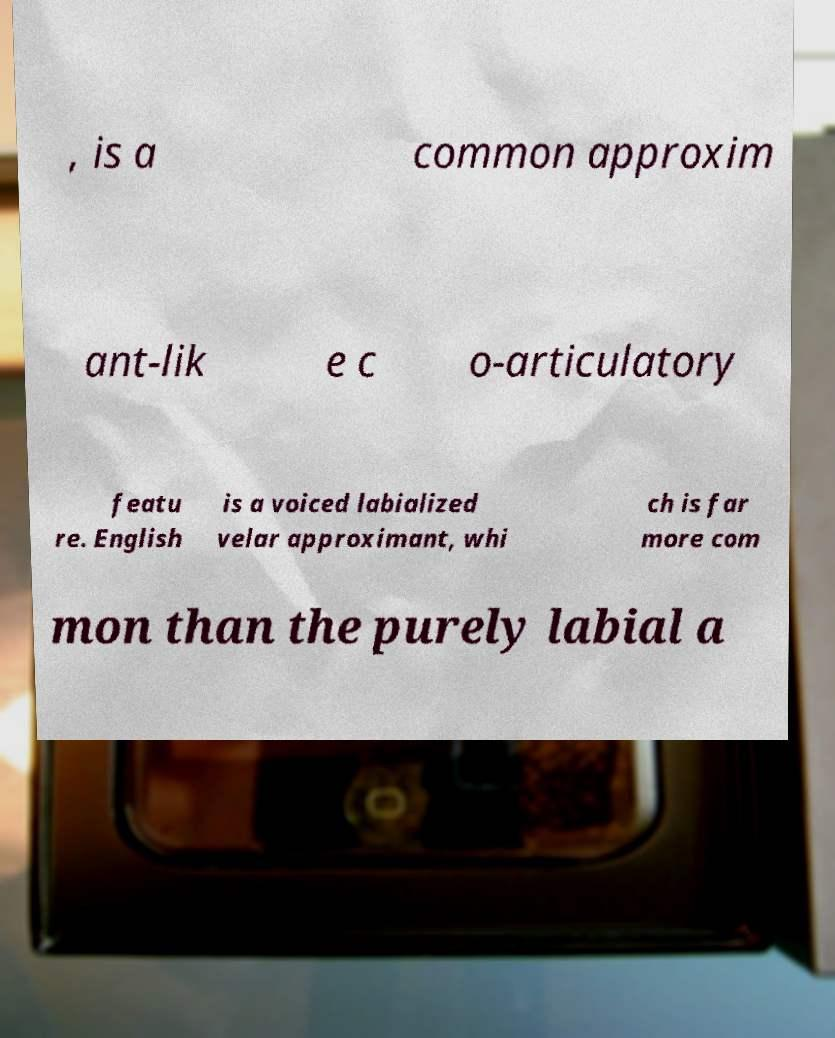Please read and relay the text visible in this image. What does it say? , is a common approxim ant-lik e c o-articulatory featu re. English is a voiced labialized velar approximant, whi ch is far more com mon than the purely labial a 